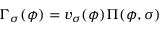<formula> <loc_0><loc_0><loc_500><loc_500>\Gamma _ { \sigma } ( \phi ) = v _ { \sigma } ( \phi ) \Pi ( \phi , \sigma )</formula> 